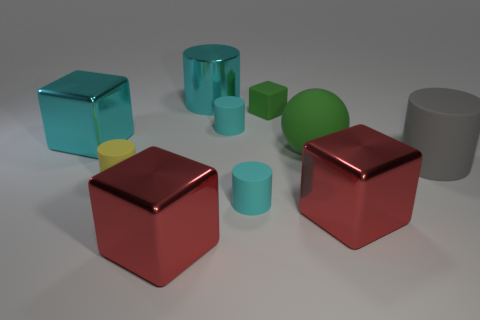Subtract all cyan cylinders. How many were subtracted if there are1cyan cylinders left? 2 Subtract all yellow cubes. How many cyan cylinders are left? 3 Subtract all large cyan cylinders. How many cylinders are left? 4 Subtract all gray cylinders. How many cylinders are left? 4 Subtract all red cylinders. Subtract all gray blocks. How many cylinders are left? 5 Subtract all blocks. How many objects are left? 6 Add 1 big cylinders. How many big cylinders exist? 3 Subtract 0 blue cylinders. How many objects are left? 10 Subtract all cylinders. Subtract all big red metallic objects. How many objects are left? 3 Add 1 large rubber balls. How many large rubber balls are left? 2 